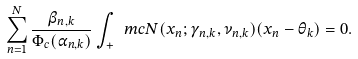Convert formula to latex. <formula><loc_0><loc_0><loc_500><loc_500>\sum _ { n = 1 } ^ { N } \frac { \beta _ { n , k } } { \Phi _ { c } ( \alpha _ { n , k } ) } \int _ { + } \ m c { N } ( x _ { n } ; \gamma _ { n , k } , \nu _ { n , k } ) ( x _ { n } - \theta _ { k } ) = 0 .</formula> 